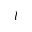Convert formula to latex. <formula><loc_0><loc_0><loc_500><loc_500>l</formula> 